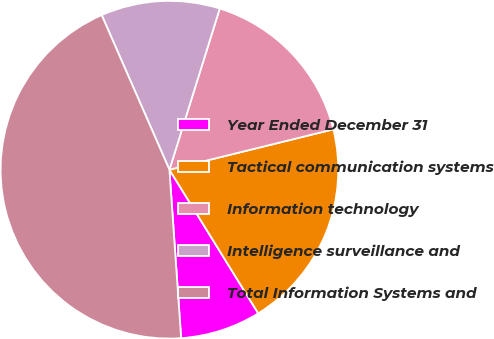<chart> <loc_0><loc_0><loc_500><loc_500><pie_chart><fcel>Year Ended December 31<fcel>Tactical communication systems<fcel>Information technology<fcel>Intelligence surveillance and<fcel>Total Information Systems and<nl><fcel>7.71%<fcel>20.03%<fcel>16.34%<fcel>11.39%<fcel>44.53%<nl></chart> 